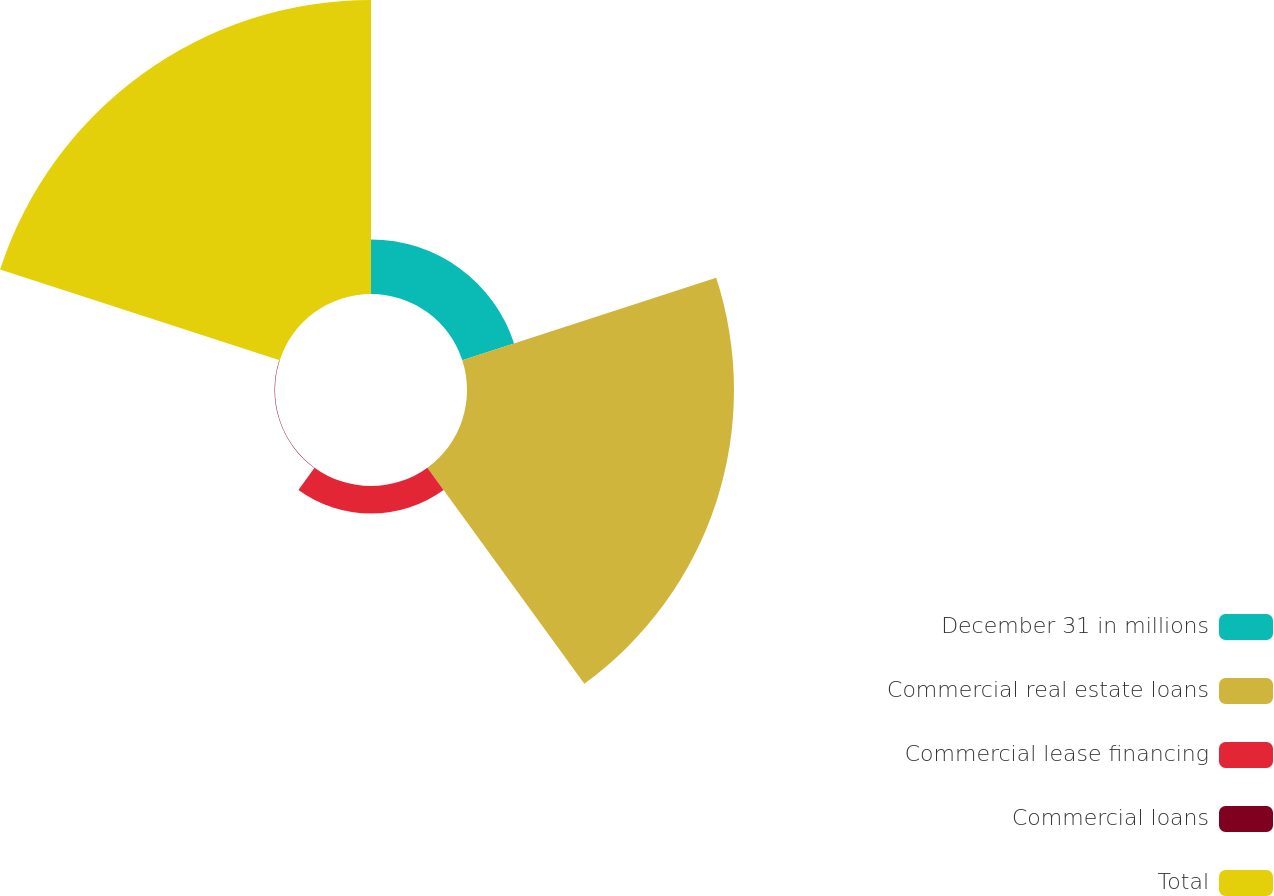<chart> <loc_0><loc_0><loc_500><loc_500><pie_chart><fcel>December 31 in millions<fcel>Commercial real estate loans<fcel>Commercial lease financing<fcel>Commercial loans<fcel>Total<nl><fcel>8.47%<fcel>41.49%<fcel>4.27%<fcel>0.07%<fcel>45.69%<nl></chart> 